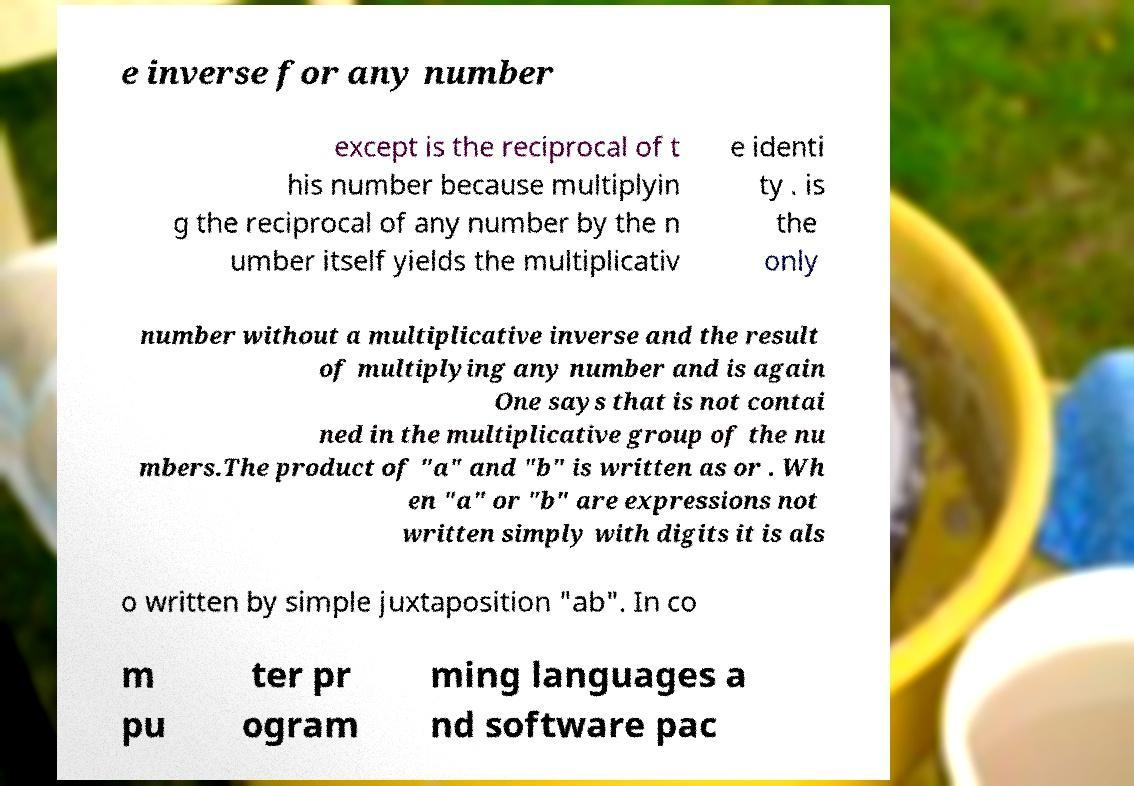I need the written content from this picture converted into text. Can you do that? e inverse for any number except is the reciprocal of t his number because multiplyin g the reciprocal of any number by the n umber itself yields the multiplicativ e identi ty . is the only number without a multiplicative inverse and the result of multiplying any number and is again One says that is not contai ned in the multiplicative group of the nu mbers.The product of "a" and "b" is written as or . Wh en "a" or "b" are expressions not written simply with digits it is als o written by simple juxtaposition "ab". In co m pu ter pr ogram ming languages a nd software pac 